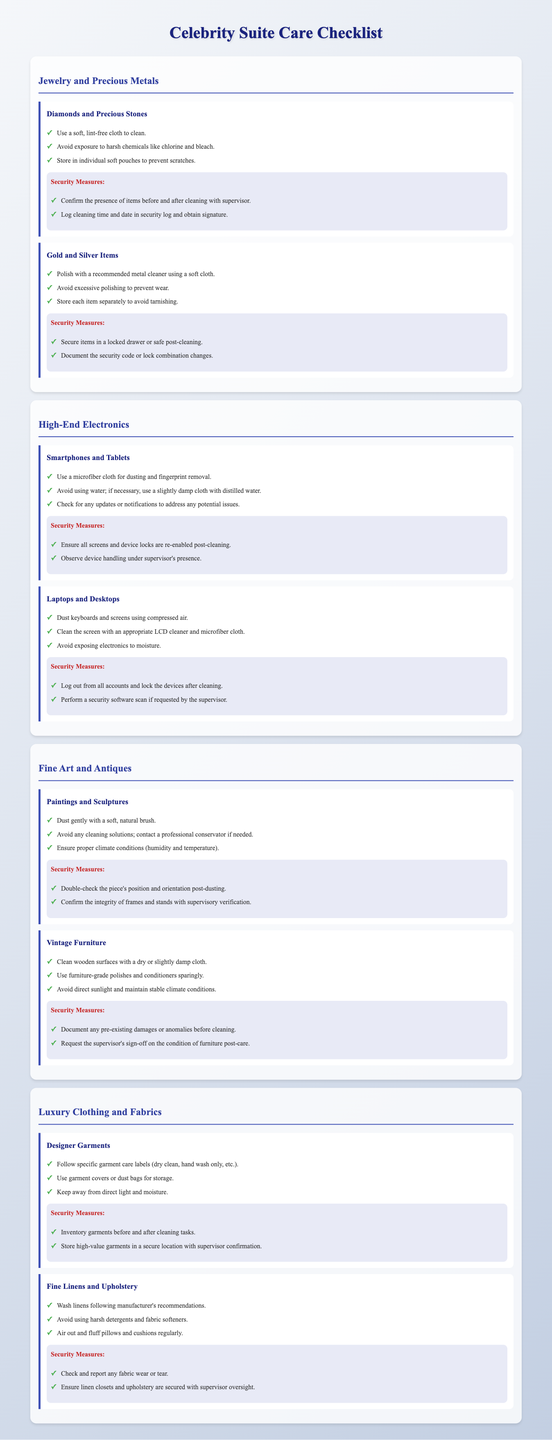What should be used to clean diamonds and precious stones? The document specifies that a soft, lint-free cloth should be used to clean diamonds and precious stones.
Answer: soft, lint-free cloth What is the recommended storage method for gold and silver items? The checklist indicates that each item should be stored separately to avoid tarnishing.
Answer: separately Which high-end electronic devices require dusting with a microfiber cloth? The document mentions that smartphones and tablets require dusting with a microfiber cloth for cleaning.
Answer: smartphones and tablets What is the security measure for fine art and antiques after dusting? The document states that the position and orientation of the piece should be double-checked post-dusting as a security measure.
Answer: double-check the piece's position and orientation How is vintage furniture recommended to be cleaned? The checklist advises cleaning wooden surfaces with a dry or slightly damp cloth for vintage furniture.
Answer: dry or slightly damp cloth What is the purpose of documenting pre-existing damages for vintage furniture? It is required as a security measure before carrying out any cleaning tasks, according to the document.
Answer: security measure What type of care should be followed for designer garments? The document specifies that specific garment care labels should be followed based on their washing instructions.
Answer: follow specific garment care labels What cleaning action is suggested for fine linens? The checklist recommends washing linens following the manufacturer's recommendations.
Answer: wash following manufacturer's recommendations Which security measure is needed for valuable garments? The document states that an inventory of garments should be taken before and after cleaning tasks as a security measure.
Answer: inventory garments 